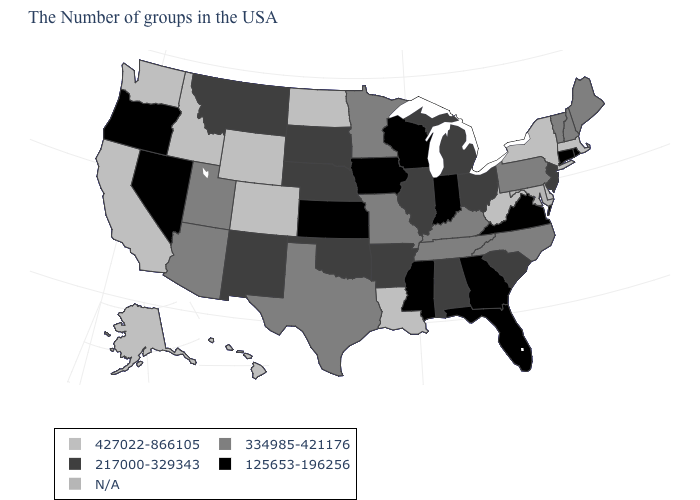What is the value of Alaska?
Concise answer only. 427022-866105. What is the value of Utah?
Write a very short answer. 334985-421176. What is the value of Washington?
Short answer required. 427022-866105. Is the legend a continuous bar?
Short answer required. No. What is the value of Iowa?
Quick response, please. 125653-196256. What is the highest value in the USA?
Concise answer only. 427022-866105. Name the states that have a value in the range 334985-421176?
Write a very short answer. Maine, New Hampshire, Vermont, Pennsylvania, North Carolina, Kentucky, Tennessee, Missouri, Minnesota, Texas, Utah, Arizona. What is the value of Alabama?
Keep it brief. 217000-329343. Does Pennsylvania have the lowest value in the USA?
Write a very short answer. No. Which states have the highest value in the USA?
Be succinct. Massachusetts, New York, Delaware, West Virginia, Louisiana, North Dakota, Wyoming, Colorado, Idaho, California, Washington, Alaska, Hawaii. Name the states that have a value in the range 427022-866105?
Give a very brief answer. Massachusetts, New York, Delaware, West Virginia, Louisiana, North Dakota, Wyoming, Colorado, Idaho, California, Washington, Alaska, Hawaii. Name the states that have a value in the range N/A?
Short answer required. Maryland. What is the lowest value in the MidWest?
Give a very brief answer. 125653-196256. 